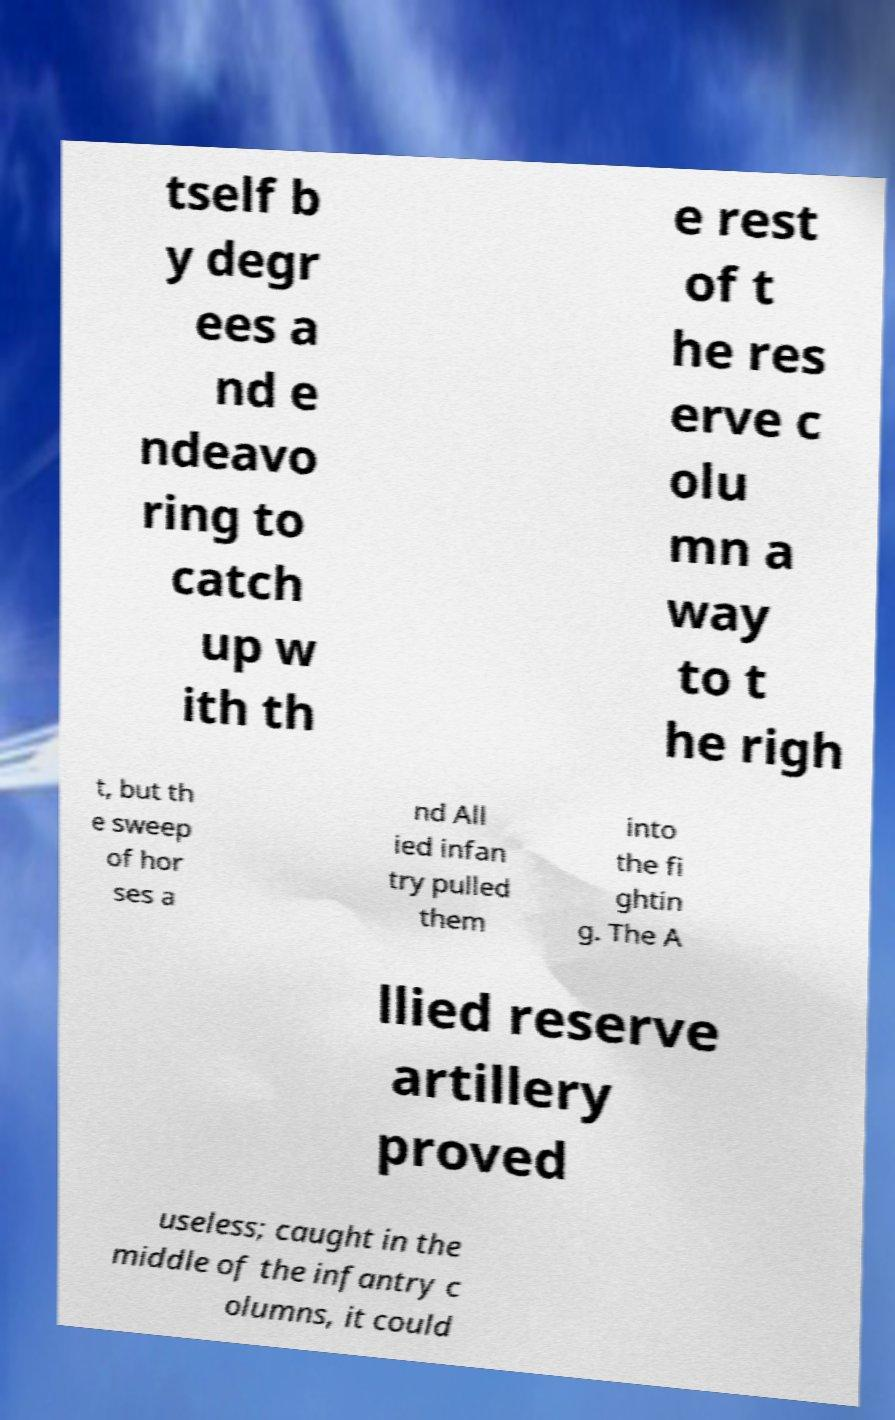Could you assist in decoding the text presented in this image and type it out clearly? tself b y degr ees a nd e ndeavo ring to catch up w ith th e rest of t he res erve c olu mn a way to t he righ t, but th e sweep of hor ses a nd All ied infan try pulled them into the fi ghtin g. The A llied reserve artillery proved useless; caught in the middle of the infantry c olumns, it could 